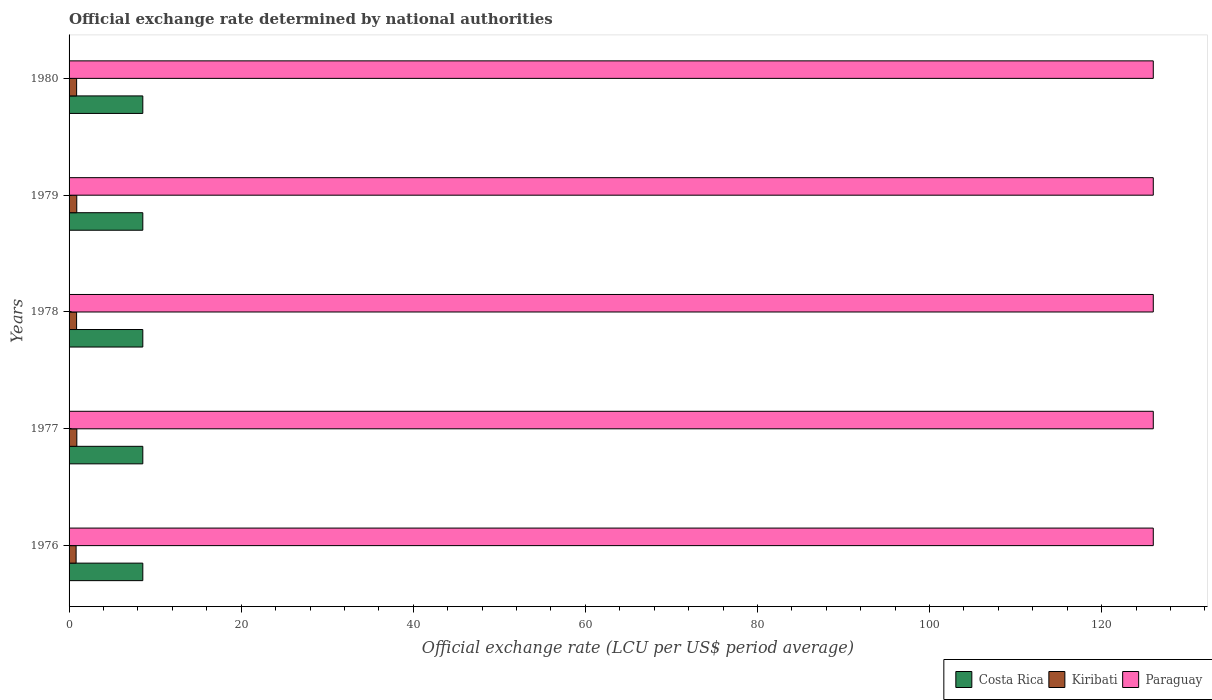Are the number of bars per tick equal to the number of legend labels?
Offer a terse response. Yes. How many bars are there on the 2nd tick from the bottom?
Offer a terse response. 3. What is the label of the 5th group of bars from the top?
Give a very brief answer. 1976. In how many cases, is the number of bars for a given year not equal to the number of legend labels?
Your answer should be compact. 0. What is the official exchange rate in Paraguay in 1979?
Give a very brief answer. 126. Across all years, what is the maximum official exchange rate in Kiribati?
Your answer should be very brief. 0.9. Across all years, what is the minimum official exchange rate in Paraguay?
Your response must be concise. 126. In which year was the official exchange rate in Kiribati maximum?
Make the answer very short. 1977. In which year was the official exchange rate in Kiribati minimum?
Your response must be concise. 1976. What is the total official exchange rate in Paraguay in the graph?
Your answer should be very brief. 630. What is the difference between the official exchange rate in Kiribati in 1980 and the official exchange rate in Paraguay in 1977?
Your answer should be compact. -125.12. What is the average official exchange rate in Costa Rica per year?
Provide a succinct answer. 8.57. In the year 1978, what is the difference between the official exchange rate in Kiribati and official exchange rate in Costa Rica?
Provide a short and direct response. -7.7. What is the ratio of the official exchange rate in Kiribati in 1977 to that in 1979?
Provide a short and direct response. 1.01. Is the difference between the official exchange rate in Kiribati in 1976 and 1978 greater than the difference between the official exchange rate in Costa Rica in 1976 and 1978?
Your answer should be compact. No. What is the difference between the highest and the second highest official exchange rate in Costa Rica?
Your answer should be compact. 8.333067569310515e-11. What is the difference between the highest and the lowest official exchange rate in Costa Rica?
Offer a very short reply. 8.333067569310515e-11. What does the 3rd bar from the top in 1980 represents?
Provide a succinct answer. Costa Rica. What does the 1st bar from the bottom in 1977 represents?
Provide a succinct answer. Costa Rica. Is it the case that in every year, the sum of the official exchange rate in Costa Rica and official exchange rate in Paraguay is greater than the official exchange rate in Kiribati?
Provide a succinct answer. Yes. How many bars are there?
Offer a very short reply. 15. What is the difference between two consecutive major ticks on the X-axis?
Make the answer very short. 20. Are the values on the major ticks of X-axis written in scientific E-notation?
Your answer should be very brief. No. Does the graph contain any zero values?
Make the answer very short. No. Does the graph contain grids?
Your answer should be compact. No. Where does the legend appear in the graph?
Your response must be concise. Bottom right. How many legend labels are there?
Provide a short and direct response. 3. How are the legend labels stacked?
Offer a terse response. Horizontal. What is the title of the graph?
Your response must be concise. Official exchange rate determined by national authorities. Does "West Bank and Gaza" appear as one of the legend labels in the graph?
Make the answer very short. No. What is the label or title of the X-axis?
Your response must be concise. Official exchange rate (LCU per US$ period average). What is the label or title of the Y-axis?
Offer a very short reply. Years. What is the Official exchange rate (LCU per US$ period average) in Costa Rica in 1976?
Make the answer very short. 8.57. What is the Official exchange rate (LCU per US$ period average) in Kiribati in 1976?
Make the answer very short. 0.82. What is the Official exchange rate (LCU per US$ period average) in Paraguay in 1976?
Give a very brief answer. 126. What is the Official exchange rate (LCU per US$ period average) in Costa Rica in 1977?
Ensure brevity in your answer.  8.57. What is the Official exchange rate (LCU per US$ period average) in Kiribati in 1977?
Your answer should be very brief. 0.9. What is the Official exchange rate (LCU per US$ period average) in Paraguay in 1977?
Offer a very short reply. 126. What is the Official exchange rate (LCU per US$ period average) of Costa Rica in 1978?
Provide a succinct answer. 8.57. What is the Official exchange rate (LCU per US$ period average) of Kiribati in 1978?
Provide a succinct answer. 0.87. What is the Official exchange rate (LCU per US$ period average) of Paraguay in 1978?
Keep it short and to the point. 126. What is the Official exchange rate (LCU per US$ period average) of Costa Rica in 1979?
Make the answer very short. 8.57. What is the Official exchange rate (LCU per US$ period average) of Kiribati in 1979?
Ensure brevity in your answer.  0.89. What is the Official exchange rate (LCU per US$ period average) in Paraguay in 1979?
Ensure brevity in your answer.  126. What is the Official exchange rate (LCU per US$ period average) in Costa Rica in 1980?
Ensure brevity in your answer.  8.57. What is the Official exchange rate (LCU per US$ period average) in Kiribati in 1980?
Your answer should be very brief. 0.88. What is the Official exchange rate (LCU per US$ period average) in Paraguay in 1980?
Make the answer very short. 126. Across all years, what is the maximum Official exchange rate (LCU per US$ period average) of Costa Rica?
Your response must be concise. 8.57. Across all years, what is the maximum Official exchange rate (LCU per US$ period average) in Kiribati?
Your response must be concise. 0.9. Across all years, what is the maximum Official exchange rate (LCU per US$ period average) in Paraguay?
Make the answer very short. 126. Across all years, what is the minimum Official exchange rate (LCU per US$ period average) in Costa Rica?
Provide a succinct answer. 8.57. Across all years, what is the minimum Official exchange rate (LCU per US$ period average) in Kiribati?
Offer a very short reply. 0.82. Across all years, what is the minimum Official exchange rate (LCU per US$ period average) of Paraguay?
Provide a succinct answer. 126. What is the total Official exchange rate (LCU per US$ period average) of Costa Rica in the graph?
Ensure brevity in your answer.  42.85. What is the total Official exchange rate (LCU per US$ period average) of Kiribati in the graph?
Your response must be concise. 4.37. What is the total Official exchange rate (LCU per US$ period average) of Paraguay in the graph?
Provide a succinct answer. 630. What is the difference between the Official exchange rate (LCU per US$ period average) in Costa Rica in 1976 and that in 1977?
Your response must be concise. 0. What is the difference between the Official exchange rate (LCU per US$ period average) of Kiribati in 1976 and that in 1977?
Keep it short and to the point. -0.08. What is the difference between the Official exchange rate (LCU per US$ period average) in Paraguay in 1976 and that in 1977?
Your response must be concise. 0. What is the difference between the Official exchange rate (LCU per US$ period average) in Kiribati in 1976 and that in 1978?
Offer a very short reply. -0.06. What is the difference between the Official exchange rate (LCU per US$ period average) in Paraguay in 1976 and that in 1978?
Your answer should be compact. 0. What is the difference between the Official exchange rate (LCU per US$ period average) in Costa Rica in 1976 and that in 1979?
Your answer should be very brief. 0. What is the difference between the Official exchange rate (LCU per US$ period average) of Kiribati in 1976 and that in 1979?
Make the answer very short. -0.08. What is the difference between the Official exchange rate (LCU per US$ period average) of Kiribati in 1976 and that in 1980?
Provide a succinct answer. -0.06. What is the difference between the Official exchange rate (LCU per US$ period average) in Paraguay in 1976 and that in 1980?
Provide a short and direct response. 0. What is the difference between the Official exchange rate (LCU per US$ period average) in Costa Rica in 1977 and that in 1978?
Your answer should be compact. 0. What is the difference between the Official exchange rate (LCU per US$ period average) of Kiribati in 1977 and that in 1978?
Your response must be concise. 0.03. What is the difference between the Official exchange rate (LCU per US$ period average) in Costa Rica in 1977 and that in 1979?
Make the answer very short. 0. What is the difference between the Official exchange rate (LCU per US$ period average) in Kiribati in 1977 and that in 1979?
Give a very brief answer. 0.01. What is the difference between the Official exchange rate (LCU per US$ period average) of Paraguay in 1977 and that in 1979?
Your response must be concise. 0. What is the difference between the Official exchange rate (LCU per US$ period average) in Kiribati in 1977 and that in 1980?
Your response must be concise. 0.02. What is the difference between the Official exchange rate (LCU per US$ period average) of Costa Rica in 1978 and that in 1979?
Your answer should be compact. 0. What is the difference between the Official exchange rate (LCU per US$ period average) of Kiribati in 1978 and that in 1979?
Offer a very short reply. -0.02. What is the difference between the Official exchange rate (LCU per US$ period average) in Kiribati in 1978 and that in 1980?
Provide a short and direct response. -0. What is the difference between the Official exchange rate (LCU per US$ period average) of Paraguay in 1978 and that in 1980?
Offer a terse response. 0. What is the difference between the Official exchange rate (LCU per US$ period average) of Kiribati in 1979 and that in 1980?
Provide a short and direct response. 0.02. What is the difference between the Official exchange rate (LCU per US$ period average) in Paraguay in 1979 and that in 1980?
Ensure brevity in your answer.  0. What is the difference between the Official exchange rate (LCU per US$ period average) in Costa Rica in 1976 and the Official exchange rate (LCU per US$ period average) in Kiribati in 1977?
Your response must be concise. 7.67. What is the difference between the Official exchange rate (LCU per US$ period average) of Costa Rica in 1976 and the Official exchange rate (LCU per US$ period average) of Paraguay in 1977?
Offer a terse response. -117.43. What is the difference between the Official exchange rate (LCU per US$ period average) of Kiribati in 1976 and the Official exchange rate (LCU per US$ period average) of Paraguay in 1977?
Give a very brief answer. -125.18. What is the difference between the Official exchange rate (LCU per US$ period average) in Costa Rica in 1976 and the Official exchange rate (LCU per US$ period average) in Kiribati in 1978?
Your answer should be compact. 7.7. What is the difference between the Official exchange rate (LCU per US$ period average) in Costa Rica in 1976 and the Official exchange rate (LCU per US$ period average) in Paraguay in 1978?
Offer a terse response. -117.43. What is the difference between the Official exchange rate (LCU per US$ period average) in Kiribati in 1976 and the Official exchange rate (LCU per US$ period average) in Paraguay in 1978?
Your response must be concise. -125.18. What is the difference between the Official exchange rate (LCU per US$ period average) in Costa Rica in 1976 and the Official exchange rate (LCU per US$ period average) in Kiribati in 1979?
Ensure brevity in your answer.  7.68. What is the difference between the Official exchange rate (LCU per US$ period average) in Costa Rica in 1976 and the Official exchange rate (LCU per US$ period average) in Paraguay in 1979?
Provide a succinct answer. -117.43. What is the difference between the Official exchange rate (LCU per US$ period average) in Kiribati in 1976 and the Official exchange rate (LCU per US$ period average) in Paraguay in 1979?
Offer a terse response. -125.18. What is the difference between the Official exchange rate (LCU per US$ period average) of Costa Rica in 1976 and the Official exchange rate (LCU per US$ period average) of Kiribati in 1980?
Your answer should be compact. 7.69. What is the difference between the Official exchange rate (LCU per US$ period average) in Costa Rica in 1976 and the Official exchange rate (LCU per US$ period average) in Paraguay in 1980?
Provide a succinct answer. -117.43. What is the difference between the Official exchange rate (LCU per US$ period average) in Kiribati in 1976 and the Official exchange rate (LCU per US$ period average) in Paraguay in 1980?
Give a very brief answer. -125.18. What is the difference between the Official exchange rate (LCU per US$ period average) in Costa Rica in 1977 and the Official exchange rate (LCU per US$ period average) in Kiribati in 1978?
Ensure brevity in your answer.  7.7. What is the difference between the Official exchange rate (LCU per US$ period average) of Costa Rica in 1977 and the Official exchange rate (LCU per US$ period average) of Paraguay in 1978?
Offer a terse response. -117.43. What is the difference between the Official exchange rate (LCU per US$ period average) of Kiribati in 1977 and the Official exchange rate (LCU per US$ period average) of Paraguay in 1978?
Make the answer very short. -125.1. What is the difference between the Official exchange rate (LCU per US$ period average) of Costa Rica in 1977 and the Official exchange rate (LCU per US$ period average) of Kiribati in 1979?
Your answer should be very brief. 7.68. What is the difference between the Official exchange rate (LCU per US$ period average) in Costa Rica in 1977 and the Official exchange rate (LCU per US$ period average) in Paraguay in 1979?
Your response must be concise. -117.43. What is the difference between the Official exchange rate (LCU per US$ period average) in Kiribati in 1977 and the Official exchange rate (LCU per US$ period average) in Paraguay in 1979?
Give a very brief answer. -125.1. What is the difference between the Official exchange rate (LCU per US$ period average) in Costa Rica in 1977 and the Official exchange rate (LCU per US$ period average) in Kiribati in 1980?
Ensure brevity in your answer.  7.69. What is the difference between the Official exchange rate (LCU per US$ period average) in Costa Rica in 1977 and the Official exchange rate (LCU per US$ period average) in Paraguay in 1980?
Give a very brief answer. -117.43. What is the difference between the Official exchange rate (LCU per US$ period average) of Kiribati in 1977 and the Official exchange rate (LCU per US$ period average) of Paraguay in 1980?
Offer a very short reply. -125.1. What is the difference between the Official exchange rate (LCU per US$ period average) in Costa Rica in 1978 and the Official exchange rate (LCU per US$ period average) in Kiribati in 1979?
Provide a short and direct response. 7.68. What is the difference between the Official exchange rate (LCU per US$ period average) in Costa Rica in 1978 and the Official exchange rate (LCU per US$ period average) in Paraguay in 1979?
Offer a very short reply. -117.43. What is the difference between the Official exchange rate (LCU per US$ period average) of Kiribati in 1978 and the Official exchange rate (LCU per US$ period average) of Paraguay in 1979?
Offer a very short reply. -125.13. What is the difference between the Official exchange rate (LCU per US$ period average) in Costa Rica in 1978 and the Official exchange rate (LCU per US$ period average) in Kiribati in 1980?
Give a very brief answer. 7.69. What is the difference between the Official exchange rate (LCU per US$ period average) of Costa Rica in 1978 and the Official exchange rate (LCU per US$ period average) of Paraguay in 1980?
Keep it short and to the point. -117.43. What is the difference between the Official exchange rate (LCU per US$ period average) of Kiribati in 1978 and the Official exchange rate (LCU per US$ period average) of Paraguay in 1980?
Your answer should be compact. -125.13. What is the difference between the Official exchange rate (LCU per US$ period average) of Costa Rica in 1979 and the Official exchange rate (LCU per US$ period average) of Kiribati in 1980?
Keep it short and to the point. 7.69. What is the difference between the Official exchange rate (LCU per US$ period average) of Costa Rica in 1979 and the Official exchange rate (LCU per US$ period average) of Paraguay in 1980?
Give a very brief answer. -117.43. What is the difference between the Official exchange rate (LCU per US$ period average) of Kiribati in 1979 and the Official exchange rate (LCU per US$ period average) of Paraguay in 1980?
Keep it short and to the point. -125.11. What is the average Official exchange rate (LCU per US$ period average) of Costa Rica per year?
Keep it short and to the point. 8.57. What is the average Official exchange rate (LCU per US$ period average) in Kiribati per year?
Your answer should be compact. 0.87. What is the average Official exchange rate (LCU per US$ period average) of Paraguay per year?
Your response must be concise. 126. In the year 1976, what is the difference between the Official exchange rate (LCU per US$ period average) of Costa Rica and Official exchange rate (LCU per US$ period average) of Kiribati?
Your response must be concise. 7.75. In the year 1976, what is the difference between the Official exchange rate (LCU per US$ period average) in Costa Rica and Official exchange rate (LCU per US$ period average) in Paraguay?
Make the answer very short. -117.43. In the year 1976, what is the difference between the Official exchange rate (LCU per US$ period average) in Kiribati and Official exchange rate (LCU per US$ period average) in Paraguay?
Ensure brevity in your answer.  -125.18. In the year 1977, what is the difference between the Official exchange rate (LCU per US$ period average) in Costa Rica and Official exchange rate (LCU per US$ period average) in Kiribati?
Keep it short and to the point. 7.67. In the year 1977, what is the difference between the Official exchange rate (LCU per US$ period average) of Costa Rica and Official exchange rate (LCU per US$ period average) of Paraguay?
Provide a succinct answer. -117.43. In the year 1977, what is the difference between the Official exchange rate (LCU per US$ period average) in Kiribati and Official exchange rate (LCU per US$ period average) in Paraguay?
Offer a very short reply. -125.1. In the year 1978, what is the difference between the Official exchange rate (LCU per US$ period average) in Costa Rica and Official exchange rate (LCU per US$ period average) in Kiribati?
Your response must be concise. 7.7. In the year 1978, what is the difference between the Official exchange rate (LCU per US$ period average) in Costa Rica and Official exchange rate (LCU per US$ period average) in Paraguay?
Offer a terse response. -117.43. In the year 1978, what is the difference between the Official exchange rate (LCU per US$ period average) in Kiribati and Official exchange rate (LCU per US$ period average) in Paraguay?
Provide a succinct answer. -125.13. In the year 1979, what is the difference between the Official exchange rate (LCU per US$ period average) in Costa Rica and Official exchange rate (LCU per US$ period average) in Kiribati?
Provide a succinct answer. 7.68. In the year 1979, what is the difference between the Official exchange rate (LCU per US$ period average) of Costa Rica and Official exchange rate (LCU per US$ period average) of Paraguay?
Provide a short and direct response. -117.43. In the year 1979, what is the difference between the Official exchange rate (LCU per US$ period average) in Kiribati and Official exchange rate (LCU per US$ period average) in Paraguay?
Provide a succinct answer. -125.11. In the year 1980, what is the difference between the Official exchange rate (LCU per US$ period average) in Costa Rica and Official exchange rate (LCU per US$ period average) in Kiribati?
Your answer should be very brief. 7.69. In the year 1980, what is the difference between the Official exchange rate (LCU per US$ period average) in Costa Rica and Official exchange rate (LCU per US$ period average) in Paraguay?
Your answer should be very brief. -117.43. In the year 1980, what is the difference between the Official exchange rate (LCU per US$ period average) of Kiribati and Official exchange rate (LCU per US$ period average) of Paraguay?
Provide a succinct answer. -125.12. What is the ratio of the Official exchange rate (LCU per US$ period average) in Costa Rica in 1976 to that in 1977?
Offer a terse response. 1. What is the ratio of the Official exchange rate (LCU per US$ period average) of Kiribati in 1976 to that in 1977?
Give a very brief answer. 0.91. What is the ratio of the Official exchange rate (LCU per US$ period average) in Costa Rica in 1976 to that in 1978?
Offer a very short reply. 1. What is the ratio of the Official exchange rate (LCU per US$ period average) in Kiribati in 1976 to that in 1978?
Keep it short and to the point. 0.94. What is the ratio of the Official exchange rate (LCU per US$ period average) in Paraguay in 1976 to that in 1978?
Keep it short and to the point. 1. What is the ratio of the Official exchange rate (LCU per US$ period average) in Costa Rica in 1976 to that in 1979?
Offer a very short reply. 1. What is the ratio of the Official exchange rate (LCU per US$ period average) of Kiribati in 1976 to that in 1979?
Offer a very short reply. 0.91. What is the ratio of the Official exchange rate (LCU per US$ period average) in Costa Rica in 1976 to that in 1980?
Your answer should be very brief. 1. What is the ratio of the Official exchange rate (LCU per US$ period average) in Kiribati in 1976 to that in 1980?
Give a very brief answer. 0.93. What is the ratio of the Official exchange rate (LCU per US$ period average) of Paraguay in 1976 to that in 1980?
Keep it short and to the point. 1. What is the ratio of the Official exchange rate (LCU per US$ period average) in Costa Rica in 1977 to that in 1978?
Offer a very short reply. 1. What is the ratio of the Official exchange rate (LCU per US$ period average) in Kiribati in 1977 to that in 1978?
Give a very brief answer. 1.03. What is the ratio of the Official exchange rate (LCU per US$ period average) in Paraguay in 1977 to that in 1978?
Offer a terse response. 1. What is the ratio of the Official exchange rate (LCU per US$ period average) of Costa Rica in 1977 to that in 1979?
Provide a succinct answer. 1. What is the ratio of the Official exchange rate (LCU per US$ period average) in Kiribati in 1977 to that in 1979?
Ensure brevity in your answer.  1.01. What is the ratio of the Official exchange rate (LCU per US$ period average) of Paraguay in 1977 to that in 1979?
Provide a succinct answer. 1. What is the ratio of the Official exchange rate (LCU per US$ period average) of Kiribati in 1977 to that in 1980?
Make the answer very short. 1.03. What is the ratio of the Official exchange rate (LCU per US$ period average) of Paraguay in 1977 to that in 1980?
Your response must be concise. 1. What is the ratio of the Official exchange rate (LCU per US$ period average) of Costa Rica in 1978 to that in 1979?
Ensure brevity in your answer.  1. What is the ratio of the Official exchange rate (LCU per US$ period average) in Kiribati in 1978 to that in 1979?
Offer a very short reply. 0.98. What is the ratio of the Official exchange rate (LCU per US$ period average) of Paraguay in 1978 to that in 1979?
Make the answer very short. 1. What is the ratio of the Official exchange rate (LCU per US$ period average) in Costa Rica in 1978 to that in 1980?
Give a very brief answer. 1. What is the ratio of the Official exchange rate (LCU per US$ period average) of Paraguay in 1978 to that in 1980?
Offer a very short reply. 1. What is the ratio of the Official exchange rate (LCU per US$ period average) in Costa Rica in 1979 to that in 1980?
Your answer should be very brief. 1. What is the ratio of the Official exchange rate (LCU per US$ period average) in Kiribati in 1979 to that in 1980?
Provide a short and direct response. 1.02. What is the difference between the highest and the second highest Official exchange rate (LCU per US$ period average) of Kiribati?
Your response must be concise. 0.01. What is the difference between the highest and the second highest Official exchange rate (LCU per US$ period average) of Paraguay?
Keep it short and to the point. 0. What is the difference between the highest and the lowest Official exchange rate (LCU per US$ period average) in Kiribati?
Provide a succinct answer. 0.08. What is the difference between the highest and the lowest Official exchange rate (LCU per US$ period average) in Paraguay?
Give a very brief answer. 0. 